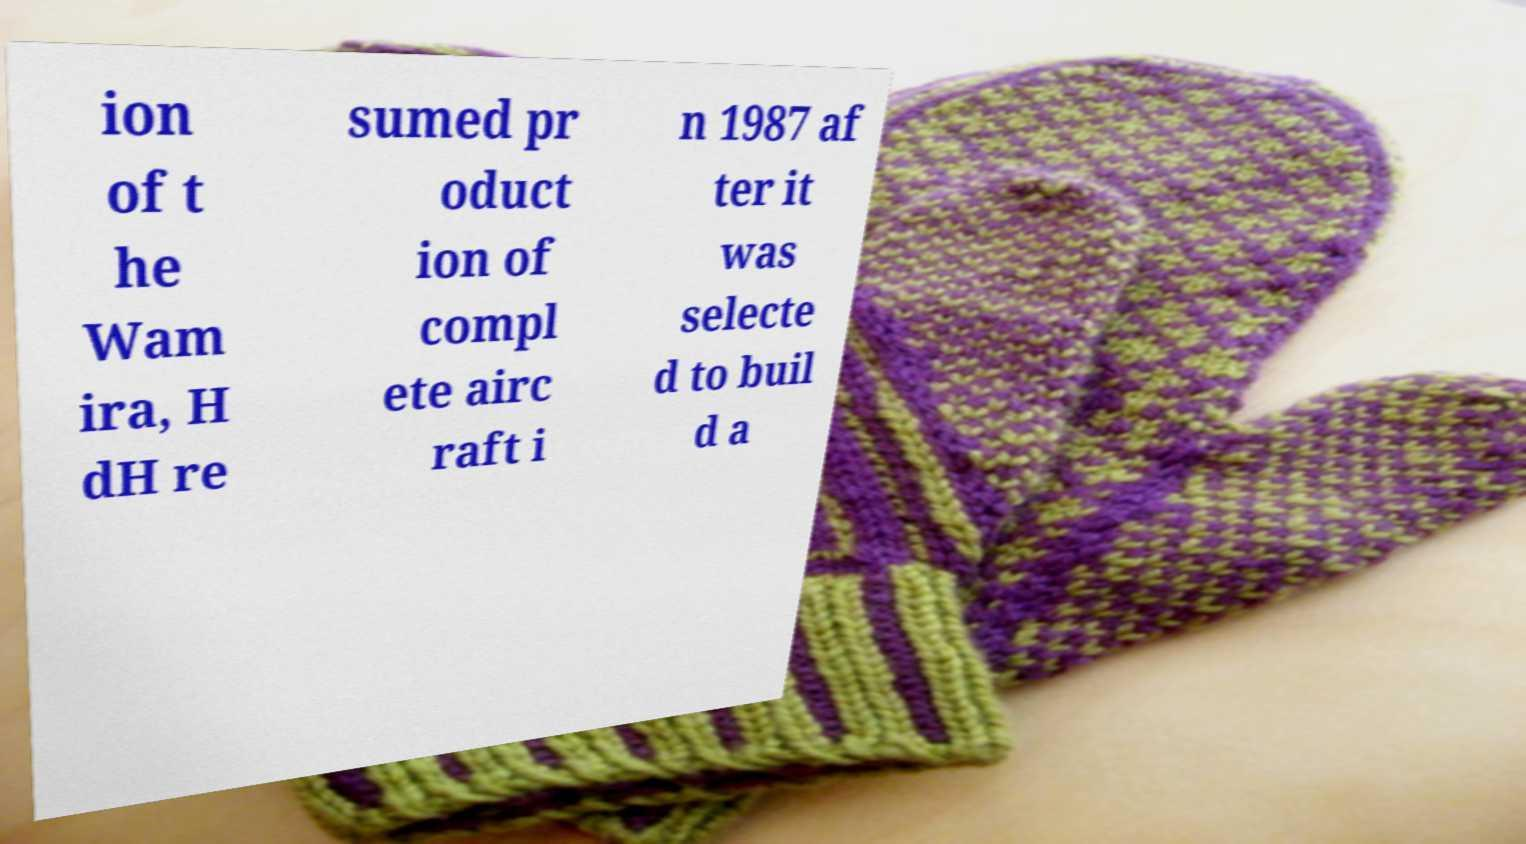There's text embedded in this image that I need extracted. Can you transcribe it verbatim? ion of t he Wam ira, H dH re sumed pr oduct ion of compl ete airc raft i n 1987 af ter it was selecte d to buil d a 